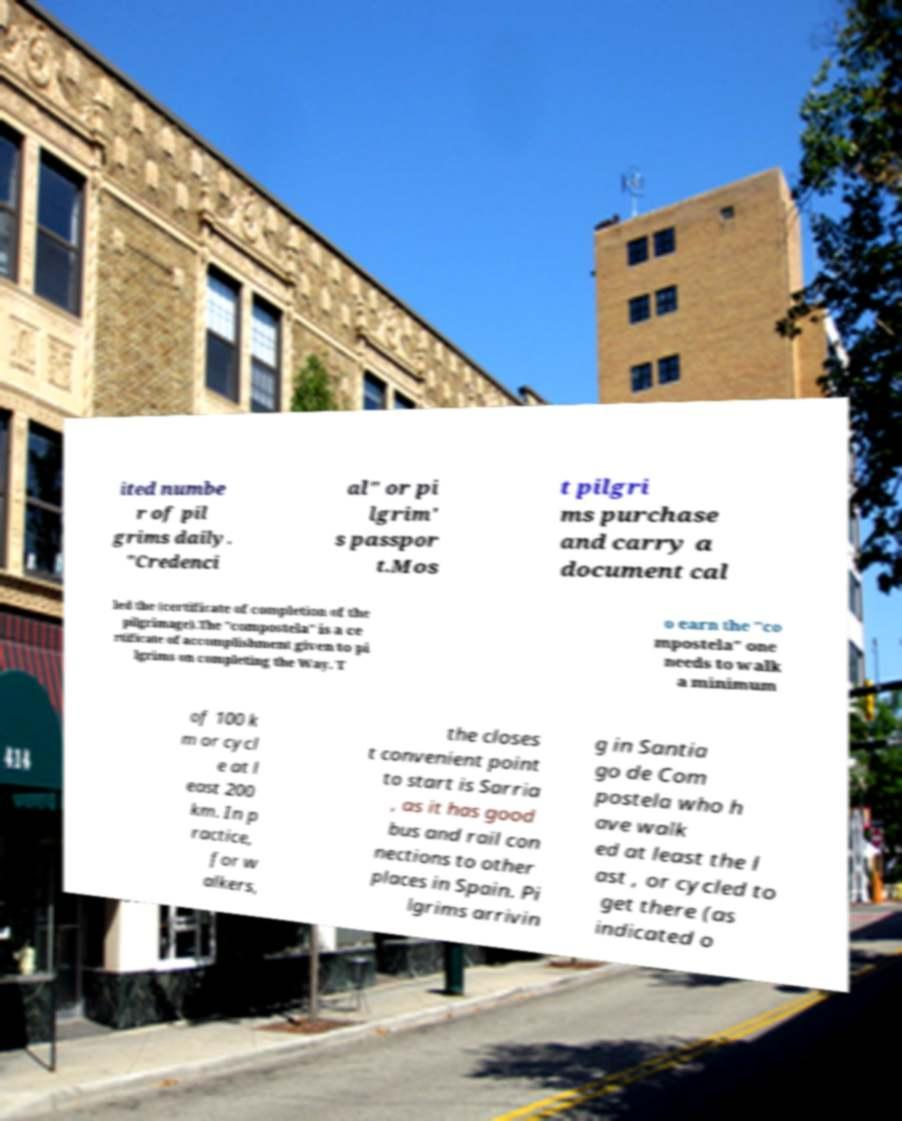Please identify and transcribe the text found in this image. ited numbe r of pil grims daily. "Credenci al" or pi lgrim' s passpor t.Mos t pilgri ms purchase and carry a document cal led the (certificate of completion of the pilgrimage).The "compostela" is a ce rtificate of accomplishment given to pi lgrims on completing the Way. T o earn the "co mpostela" one needs to walk a minimum of 100 k m or cycl e at l east 200 km. In p ractice, for w alkers, the closes t convenient point to start is Sarria , as it has good bus and rail con nections to other places in Spain. Pi lgrims arrivin g in Santia go de Com postela who h ave walk ed at least the l ast , or cycled to get there (as indicated o 